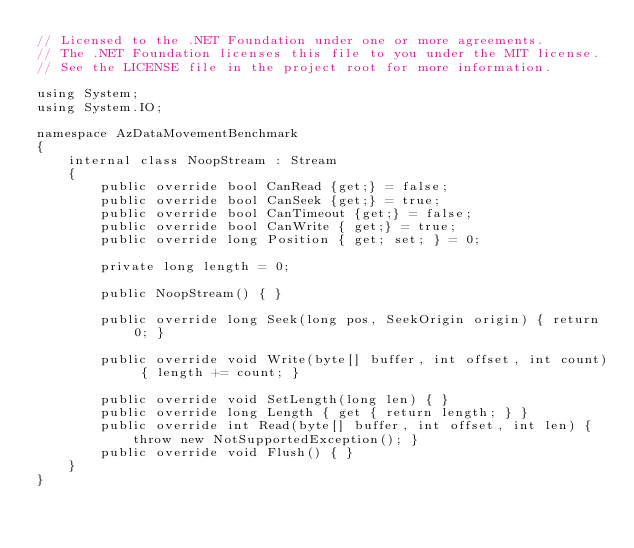<code> <loc_0><loc_0><loc_500><loc_500><_C#_>// Licensed to the .NET Foundation under one or more agreements.
// The .NET Foundation licenses this file to you under the MIT license.
// See the LICENSE file in the project root for more information.

using System;
using System.IO;

namespace AzDataMovementBenchmark
{
    internal class NoopStream : Stream
    {
        public override bool CanRead {get;} = false;
        public override bool CanSeek {get;} = true;
        public override bool CanTimeout {get;} = false;
        public override bool CanWrite { get;} = true;
        public override long Position { get; set; } = 0;

        private long length = 0;

        public NoopStream() { }

        public override long Seek(long pos, SeekOrigin origin) { return 0; }

        public override void Write(byte[] buffer, int offset, int count) { length += count; }

        public override void SetLength(long len) { }
        public override long Length { get { return length; } }
        public override int Read(byte[] buffer, int offset, int len) { throw new NotSupportedException(); }
        public override void Flush() { }
    }
}
</code> 